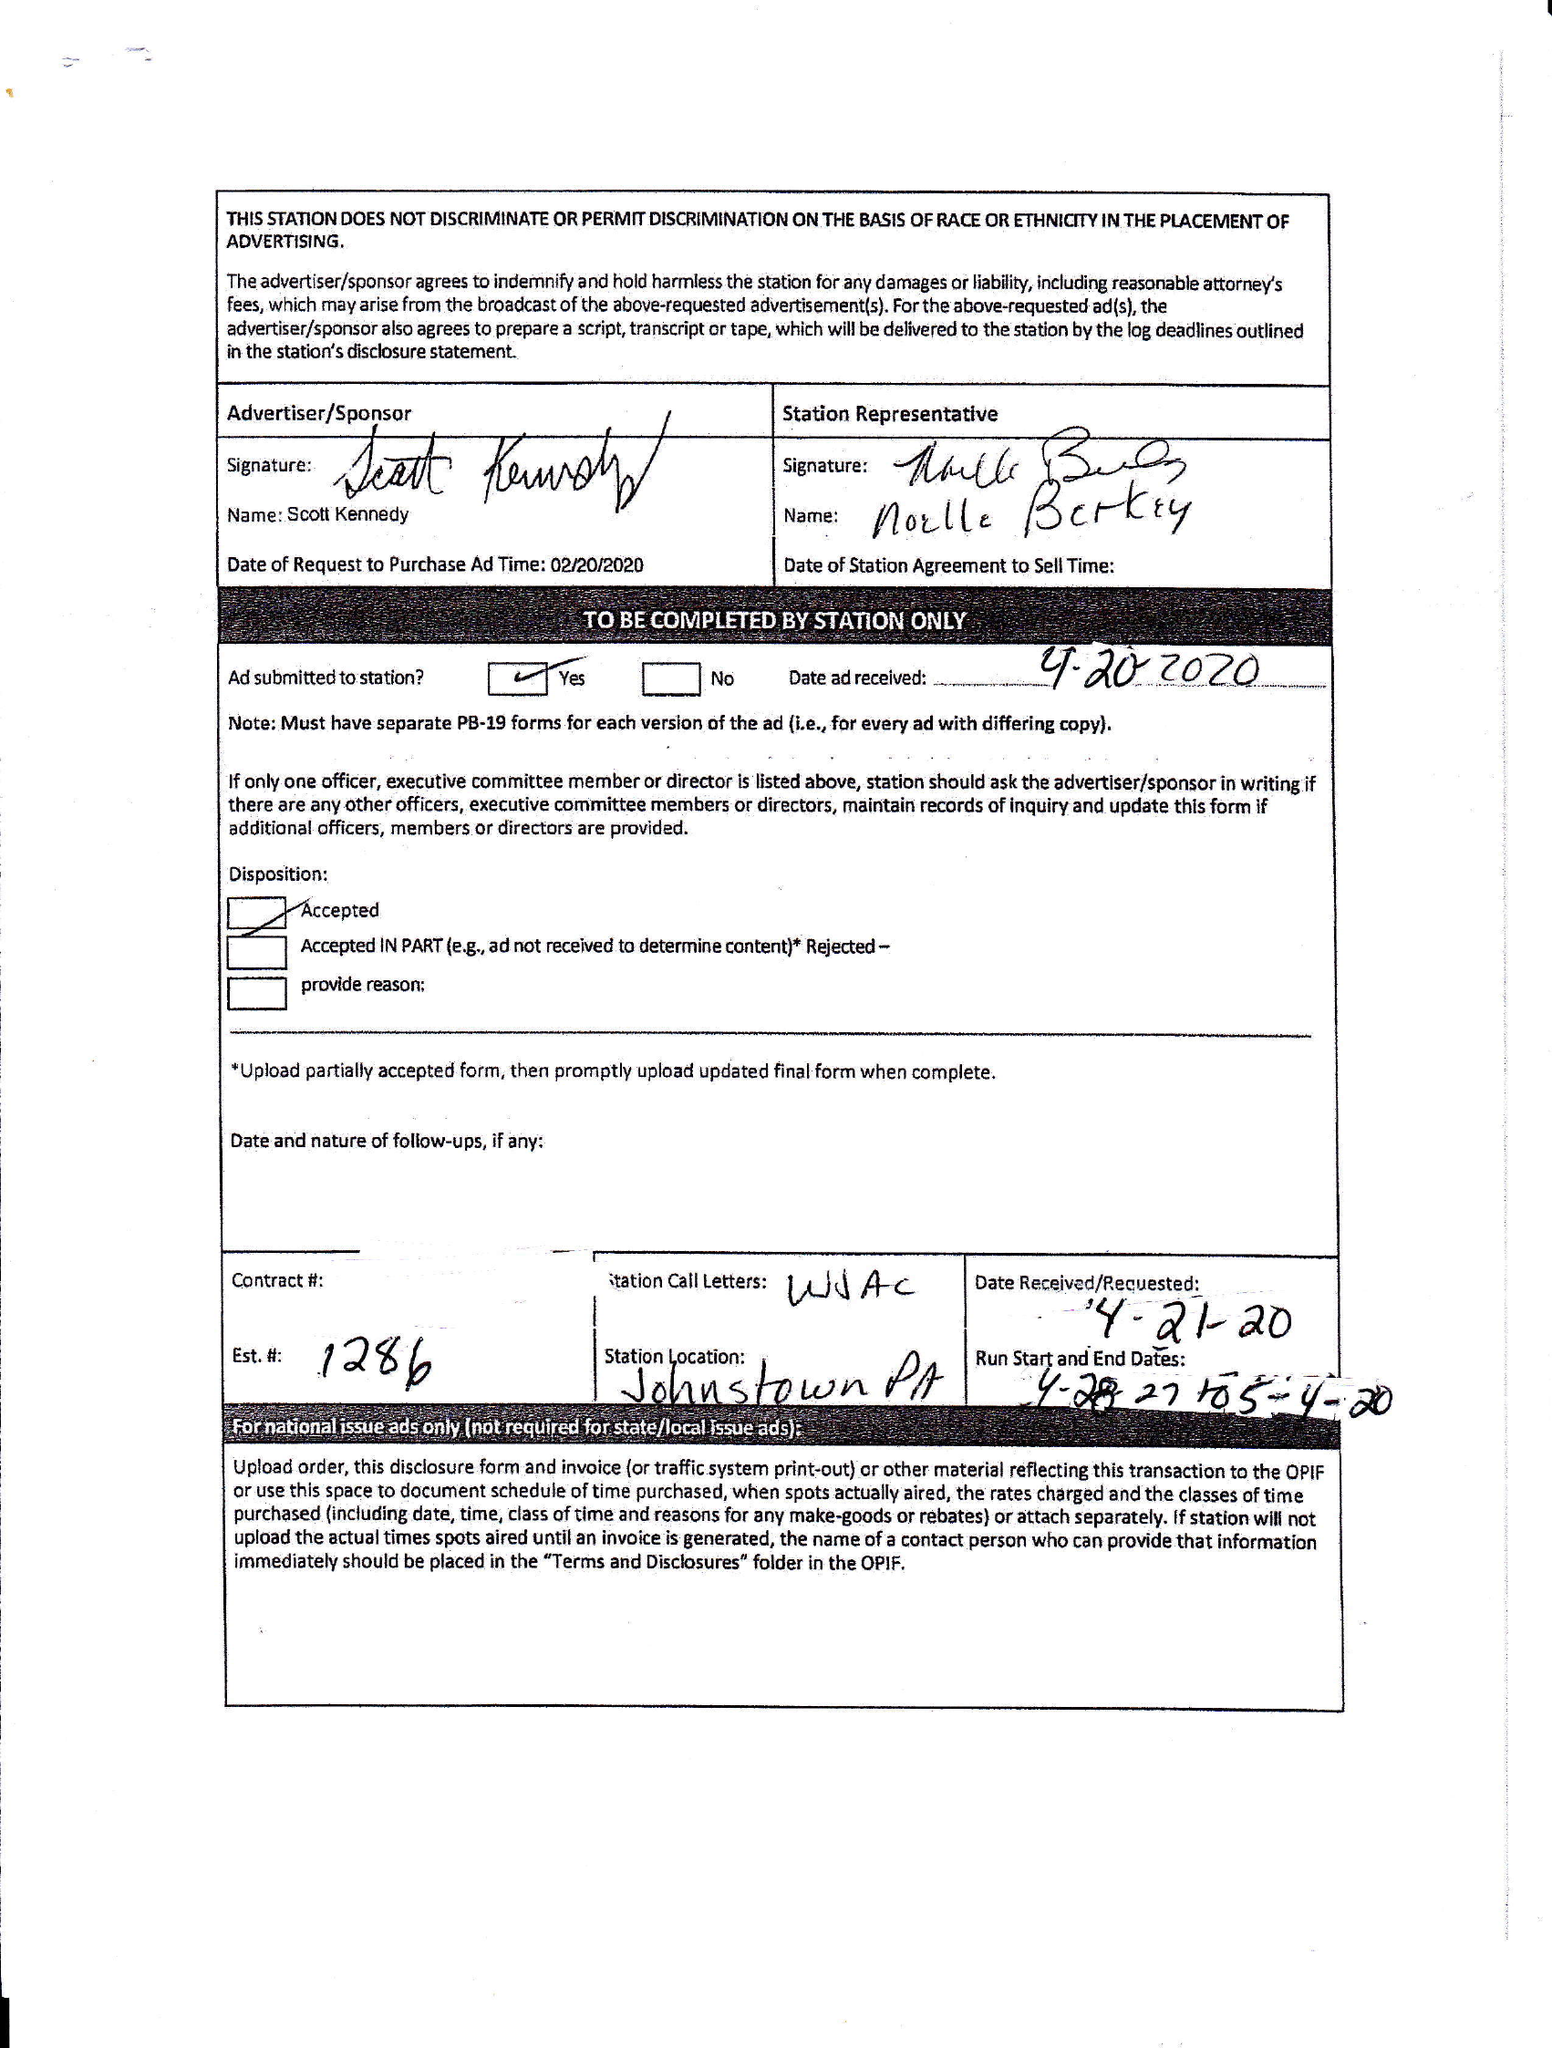What is the value for the flight_to?
Answer the question using a single word or phrase. 05/04/20 